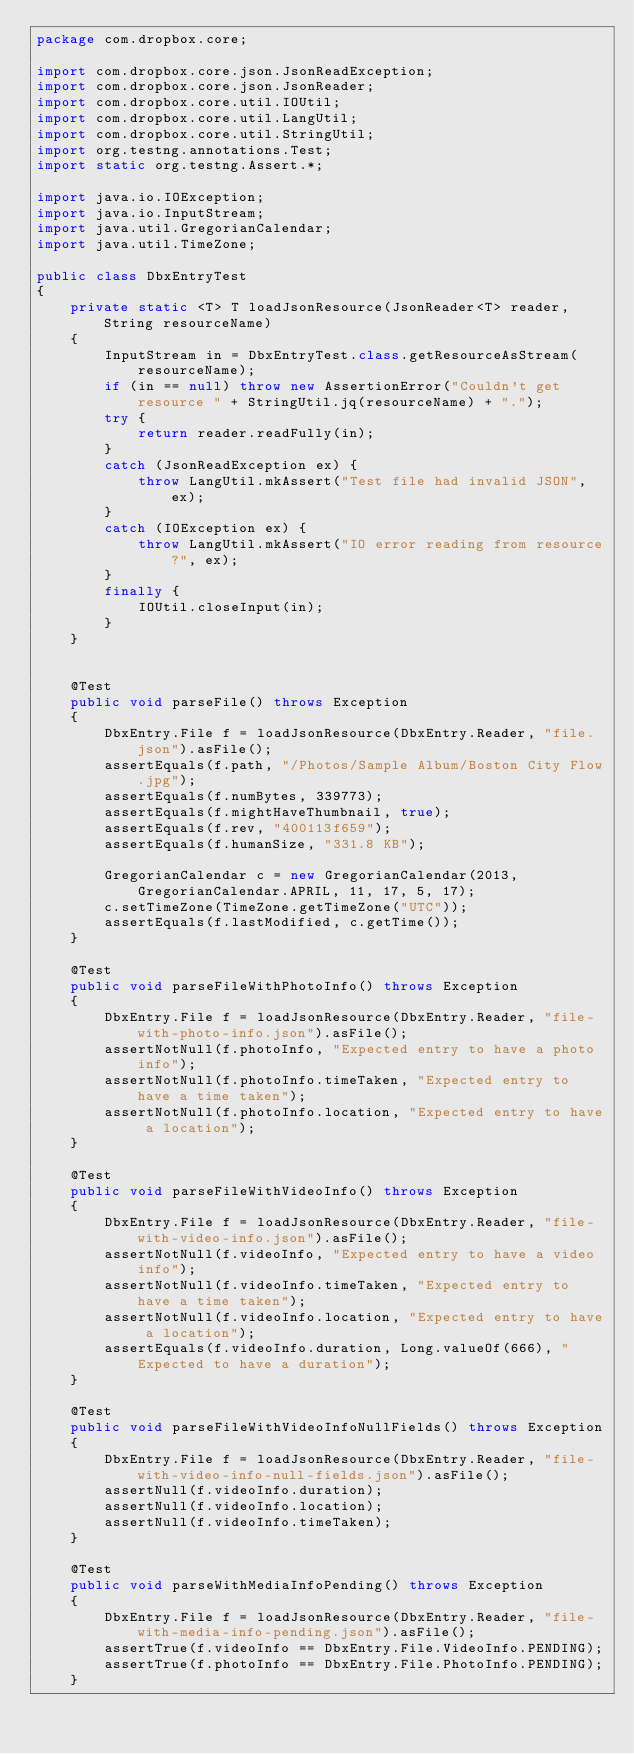Convert code to text. <code><loc_0><loc_0><loc_500><loc_500><_Java_>package com.dropbox.core;

import com.dropbox.core.json.JsonReadException;
import com.dropbox.core.json.JsonReader;
import com.dropbox.core.util.IOUtil;
import com.dropbox.core.util.LangUtil;
import com.dropbox.core.util.StringUtil;
import org.testng.annotations.Test;
import static org.testng.Assert.*;

import java.io.IOException;
import java.io.InputStream;
import java.util.GregorianCalendar;
import java.util.TimeZone;

public class DbxEntryTest
{
    private static <T> T loadJsonResource(JsonReader<T> reader, String resourceName)
    {
        InputStream in = DbxEntryTest.class.getResourceAsStream(resourceName);
        if (in == null) throw new AssertionError("Couldn't get resource " + StringUtil.jq(resourceName) + ".");
        try {
            return reader.readFully(in);
        }
        catch (JsonReadException ex) {
            throw LangUtil.mkAssert("Test file had invalid JSON", ex);
        }
        catch (IOException ex) {
            throw LangUtil.mkAssert("IO error reading from resource?", ex);
        }
        finally {
            IOUtil.closeInput(in);
        }
    }


    @Test
    public void parseFile() throws Exception
    {
        DbxEntry.File f = loadJsonResource(DbxEntry.Reader, "file.json").asFile();
        assertEquals(f.path, "/Photos/Sample Album/Boston City Flow.jpg");
        assertEquals(f.numBytes, 339773);
        assertEquals(f.mightHaveThumbnail, true);
        assertEquals(f.rev, "400113f659");
        assertEquals(f.humanSize, "331.8 KB");

        GregorianCalendar c = new GregorianCalendar(2013, GregorianCalendar.APRIL, 11, 17, 5, 17);
        c.setTimeZone(TimeZone.getTimeZone("UTC"));
        assertEquals(f.lastModified, c.getTime());
    }

    @Test
    public void parseFileWithPhotoInfo() throws Exception
    {
        DbxEntry.File f = loadJsonResource(DbxEntry.Reader, "file-with-photo-info.json").asFile();
        assertNotNull(f.photoInfo, "Expected entry to have a photo info");
        assertNotNull(f.photoInfo.timeTaken, "Expected entry to have a time taken");
        assertNotNull(f.photoInfo.location, "Expected entry to have a location");
    }

    @Test
    public void parseFileWithVideoInfo() throws Exception
    {
        DbxEntry.File f = loadJsonResource(DbxEntry.Reader, "file-with-video-info.json").asFile();
        assertNotNull(f.videoInfo, "Expected entry to have a video info");
        assertNotNull(f.videoInfo.timeTaken, "Expected entry to have a time taken");
        assertNotNull(f.videoInfo.location, "Expected entry to have a location");
        assertEquals(f.videoInfo.duration, Long.valueOf(666), "Expected to have a duration");
    }

    @Test
    public void parseFileWithVideoInfoNullFields() throws Exception
    {
        DbxEntry.File f = loadJsonResource(DbxEntry.Reader, "file-with-video-info-null-fields.json").asFile();
        assertNull(f.videoInfo.duration);
        assertNull(f.videoInfo.location);
        assertNull(f.videoInfo.timeTaken);
    }

    @Test
    public void parseWithMediaInfoPending() throws Exception
    {
        DbxEntry.File f = loadJsonResource(DbxEntry.Reader, "file-with-media-info-pending.json").asFile();
        assertTrue(f.videoInfo == DbxEntry.File.VideoInfo.PENDING);
        assertTrue(f.photoInfo == DbxEntry.File.PhotoInfo.PENDING);
    }</code> 